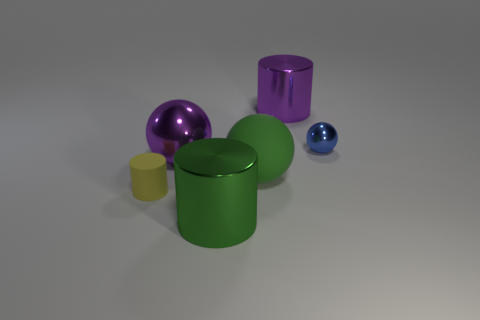Add 4 large cylinders. How many objects exist? 10 Subtract 0 red cylinders. How many objects are left? 6 Subtract all large shiny spheres. Subtract all big spheres. How many objects are left? 3 Add 6 tiny blue balls. How many tiny blue balls are left? 7 Add 3 green matte spheres. How many green matte spheres exist? 4 